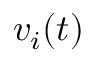Convert formula to latex. <formula><loc_0><loc_0><loc_500><loc_500>v _ { i } ( t )</formula> 